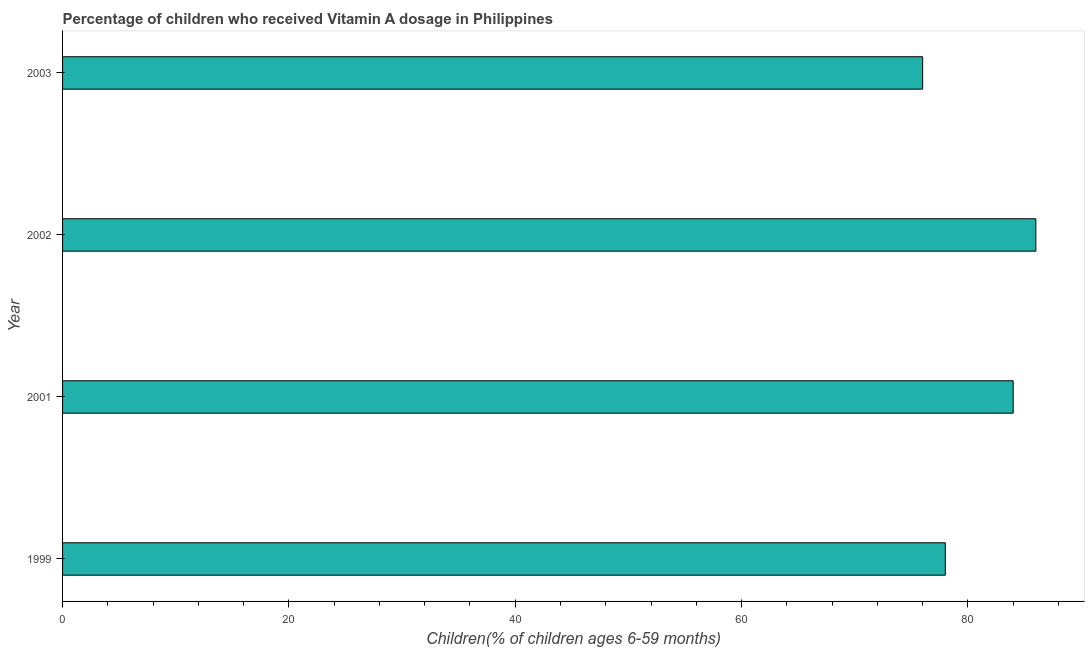What is the title of the graph?
Offer a terse response. Percentage of children who received Vitamin A dosage in Philippines. What is the label or title of the X-axis?
Keep it short and to the point. Children(% of children ages 6-59 months). What is the vitamin a supplementation coverage rate in 2002?
Provide a short and direct response. 86. Across all years, what is the maximum vitamin a supplementation coverage rate?
Offer a very short reply. 86. Across all years, what is the minimum vitamin a supplementation coverage rate?
Keep it short and to the point. 76. In which year was the vitamin a supplementation coverage rate maximum?
Offer a terse response. 2002. In which year was the vitamin a supplementation coverage rate minimum?
Your answer should be compact. 2003. What is the sum of the vitamin a supplementation coverage rate?
Make the answer very short. 324. What is the difference between the vitamin a supplementation coverage rate in 1999 and 2001?
Provide a succinct answer. -6. What is the average vitamin a supplementation coverage rate per year?
Offer a very short reply. 81. What is the median vitamin a supplementation coverage rate?
Your response must be concise. 81. What is the ratio of the vitamin a supplementation coverage rate in 2001 to that in 2003?
Your answer should be very brief. 1.1. Is the vitamin a supplementation coverage rate in 2002 less than that in 2003?
Make the answer very short. No. What is the difference between the highest and the second highest vitamin a supplementation coverage rate?
Your answer should be very brief. 2. Is the sum of the vitamin a supplementation coverage rate in 2001 and 2003 greater than the maximum vitamin a supplementation coverage rate across all years?
Offer a terse response. Yes. What is the difference between the highest and the lowest vitamin a supplementation coverage rate?
Keep it short and to the point. 10. In how many years, is the vitamin a supplementation coverage rate greater than the average vitamin a supplementation coverage rate taken over all years?
Offer a terse response. 2. How many bars are there?
Keep it short and to the point. 4. Are all the bars in the graph horizontal?
Offer a very short reply. Yes. Are the values on the major ticks of X-axis written in scientific E-notation?
Your answer should be compact. No. What is the Children(% of children ages 6-59 months) of 1999?
Ensure brevity in your answer.  78. What is the Children(% of children ages 6-59 months) in 2001?
Provide a succinct answer. 84. What is the Children(% of children ages 6-59 months) of 2003?
Provide a short and direct response. 76. What is the difference between the Children(% of children ages 6-59 months) in 1999 and 2002?
Keep it short and to the point. -8. What is the difference between the Children(% of children ages 6-59 months) in 1999 and 2003?
Your answer should be compact. 2. What is the difference between the Children(% of children ages 6-59 months) in 2002 and 2003?
Your response must be concise. 10. What is the ratio of the Children(% of children ages 6-59 months) in 1999 to that in 2001?
Offer a very short reply. 0.93. What is the ratio of the Children(% of children ages 6-59 months) in 1999 to that in 2002?
Provide a succinct answer. 0.91. What is the ratio of the Children(% of children ages 6-59 months) in 1999 to that in 2003?
Provide a succinct answer. 1.03. What is the ratio of the Children(% of children ages 6-59 months) in 2001 to that in 2003?
Offer a very short reply. 1.1. What is the ratio of the Children(% of children ages 6-59 months) in 2002 to that in 2003?
Ensure brevity in your answer.  1.13. 